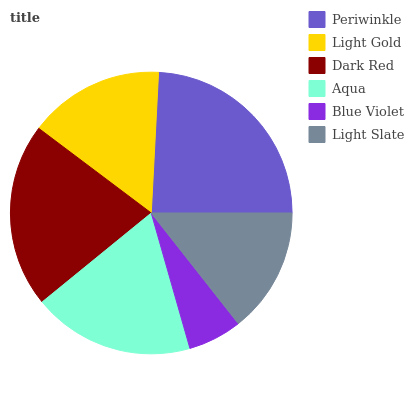Is Blue Violet the minimum?
Answer yes or no. Yes. Is Periwinkle the maximum?
Answer yes or no. Yes. Is Light Gold the minimum?
Answer yes or no. No. Is Light Gold the maximum?
Answer yes or no. No. Is Periwinkle greater than Light Gold?
Answer yes or no. Yes. Is Light Gold less than Periwinkle?
Answer yes or no. Yes. Is Light Gold greater than Periwinkle?
Answer yes or no. No. Is Periwinkle less than Light Gold?
Answer yes or no. No. Is Aqua the high median?
Answer yes or no. Yes. Is Light Gold the low median?
Answer yes or no. Yes. Is Dark Red the high median?
Answer yes or no. No. Is Light Slate the low median?
Answer yes or no. No. 